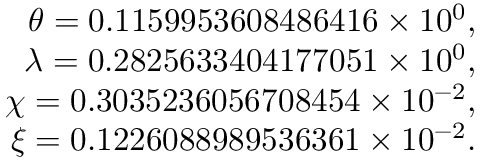<formula> <loc_0><loc_0><loc_500><loc_500>\begin{array} { r l r } & { \theta = 0 . 1 1 5 9 9 5 3 6 0 8 4 8 6 4 1 6 \times 1 0 ^ { 0 } , } \\ & { \lambda = 0 . 2 8 2 5 6 3 3 4 0 4 1 7 7 0 5 1 \times 1 0 ^ { 0 } , } \\ & { \chi = 0 . 3 0 3 5 2 3 6 0 5 6 7 0 8 4 5 4 \times 1 0 ^ { - 2 } , } \\ & { \xi = 0 . 1 2 2 6 0 8 8 9 8 9 5 3 6 3 6 1 \times 1 0 ^ { - 2 } . } \end{array}</formula> 